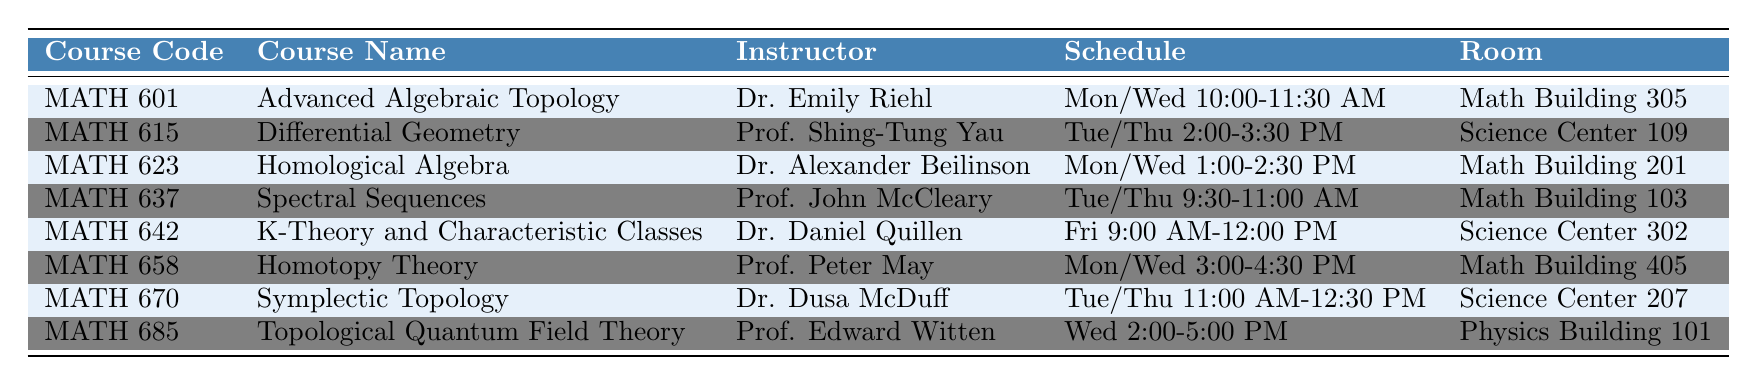What is the room number for the course "Homological Algebra"? The course "Homological Algebra" is listed in the table under the "Room" column. Specifically, the room number provided is Math Building 201.
Answer: Math Building 201 Which instructor teaches "Topological Quantum Field Theory"? The course "Topological Quantum Field Theory" is associated with Prof. Edward Witten, as per the data presented in the instructor column.
Answer: Prof. Edward Witten How many courses are scheduled on Monday? Looking at the schedule times for Monday, the courses listed include "Advanced Algebraic Topology," "Homological Algebra," and "Homotopy Theory." Therefore, there are a total of three courses held on Monday.
Answer: 3 Is "Differential Geometry" scheduled for Fridays? According to the information in the schedule section, "Differential Geometry" is scheduled for Tuesday and Thursday. There is no mention of a Friday schedule for this course, meaning it does not take place on Fridays.
Answer: No What is the total number of courses listed in the table? By reviewing the data, we find a total of eight entries representing courses in the table, confirming that there are eight courses available this semester.
Answer: 8 Which course has the earliest start time on Tuesday? On Tuesdays, we have "Differential Geometry" starting at 2:00 PM and "Symplectic Topology" starting at 11:00 AM. Since 11:00 AM is earlier than 2:00 PM, "Symplectic Topology" has the earliest start time on Tuesday.
Answer: Symplectic Topology How many instructors' names include a first name that starts with 'D'? By examining the instructor column, we find Dr. Dusa McDuff and Dr. Daniel Quillen, whose first names start with 'D'. Thus, there are two such instructors.
Answer: 2 What is the duration of the "K-Theory and Characteristic Classes" course? The course "K-Theory and Characteristic Classes" is scheduled on Fridays from 9:00 AM to 12:00 PM, which constitutes a total duration of 3 hours.
Answer: 3 hours Which course is scheduled from 2:00 PM to 5:00 PM on Wednesdays? The table shows that "Topological Quantum Field Theory" is the course scheduled on Wednesdays from 2:00 PM to 5:00 PM, as specified in the schedule column.
Answer: Topological Quantum Field Theory 